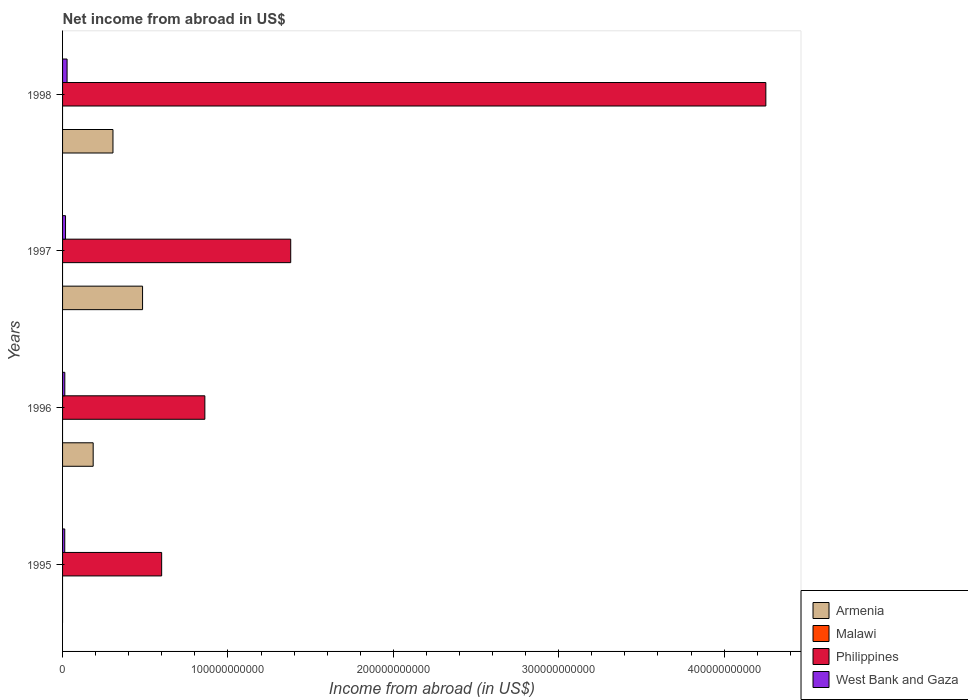Are the number of bars per tick equal to the number of legend labels?
Offer a very short reply. No. How many bars are there on the 4th tick from the bottom?
Your answer should be compact. 3. What is the label of the 2nd group of bars from the top?
Offer a very short reply. 1997. What is the net income from abroad in Philippines in 1996?
Offer a very short reply. 8.60e+1. Across all years, what is the maximum net income from abroad in Philippines?
Provide a succinct answer. 4.25e+11. In which year was the net income from abroad in Armenia maximum?
Provide a short and direct response. 1997. What is the total net income from abroad in West Bank and Gaza in the graph?
Make the answer very short. 7.20e+09. What is the difference between the net income from abroad in Philippines in 1996 and that in 1997?
Provide a short and direct response. -5.19e+1. What is the difference between the net income from abroad in Malawi in 1998 and the net income from abroad in Philippines in 1997?
Keep it short and to the point. -1.38e+11. What is the average net income from abroad in Philippines per year?
Offer a very short reply. 1.77e+11. In the year 1998, what is the difference between the net income from abroad in Armenia and net income from abroad in West Bank and Gaza?
Offer a terse response. 2.77e+1. In how many years, is the net income from abroad in Armenia greater than 420000000000 US$?
Give a very brief answer. 0. What is the ratio of the net income from abroad in Philippines in 1995 to that in 1998?
Your answer should be very brief. 0.14. Is the net income from abroad in Philippines in 1996 less than that in 1997?
Offer a very short reply. Yes. Is the difference between the net income from abroad in Armenia in 1996 and 1997 greater than the difference between the net income from abroad in West Bank and Gaza in 1996 and 1997?
Provide a succinct answer. No. What is the difference between the highest and the second highest net income from abroad in Philippines?
Provide a succinct answer. 2.87e+11. What is the difference between the highest and the lowest net income from abroad in West Bank and Gaza?
Give a very brief answer. 1.41e+09. Is the sum of the net income from abroad in West Bank and Gaza in 1995 and 1996 greater than the maximum net income from abroad in Armenia across all years?
Your answer should be very brief. No. Is it the case that in every year, the sum of the net income from abroad in West Bank and Gaza and net income from abroad in Philippines is greater than the sum of net income from abroad in Armenia and net income from abroad in Malawi?
Your answer should be very brief. Yes. How many bars are there?
Your answer should be compact. 11. Are all the bars in the graph horizontal?
Your answer should be compact. Yes. What is the difference between two consecutive major ticks on the X-axis?
Your response must be concise. 1.00e+11. Are the values on the major ticks of X-axis written in scientific E-notation?
Provide a short and direct response. No. Does the graph contain grids?
Offer a terse response. No. Where does the legend appear in the graph?
Offer a terse response. Bottom right. How are the legend labels stacked?
Make the answer very short. Vertical. What is the title of the graph?
Make the answer very short. Net income from abroad in US$. Does "Czech Republic" appear as one of the legend labels in the graph?
Make the answer very short. No. What is the label or title of the X-axis?
Give a very brief answer. Income from abroad (in US$). What is the Income from abroad (in US$) in Armenia in 1995?
Your answer should be very brief. 0. What is the Income from abroad (in US$) of Philippines in 1995?
Offer a very short reply. 5.99e+1. What is the Income from abroad (in US$) of West Bank and Gaza in 1995?
Offer a terse response. 1.32e+09. What is the Income from abroad (in US$) in Armenia in 1996?
Offer a terse response. 1.85e+1. What is the Income from abroad (in US$) of Philippines in 1996?
Ensure brevity in your answer.  8.60e+1. What is the Income from abroad (in US$) of West Bank and Gaza in 1996?
Make the answer very short. 1.35e+09. What is the Income from abroad (in US$) in Armenia in 1997?
Provide a short and direct response. 4.84e+1. What is the Income from abroad (in US$) in Malawi in 1997?
Your answer should be compact. 0. What is the Income from abroad (in US$) in Philippines in 1997?
Your answer should be compact. 1.38e+11. What is the Income from abroad (in US$) in West Bank and Gaza in 1997?
Provide a short and direct response. 1.80e+09. What is the Income from abroad (in US$) of Armenia in 1998?
Your response must be concise. 3.05e+1. What is the Income from abroad (in US$) in Philippines in 1998?
Offer a very short reply. 4.25e+11. What is the Income from abroad (in US$) in West Bank and Gaza in 1998?
Your answer should be compact. 2.73e+09. Across all years, what is the maximum Income from abroad (in US$) in Armenia?
Offer a very short reply. 4.84e+1. Across all years, what is the maximum Income from abroad (in US$) in Philippines?
Your answer should be very brief. 4.25e+11. Across all years, what is the maximum Income from abroad (in US$) in West Bank and Gaza?
Your answer should be very brief. 2.73e+09. Across all years, what is the minimum Income from abroad (in US$) in Philippines?
Keep it short and to the point. 5.99e+1. Across all years, what is the minimum Income from abroad (in US$) of West Bank and Gaza?
Your answer should be very brief. 1.32e+09. What is the total Income from abroad (in US$) of Armenia in the graph?
Your answer should be compact. 9.74e+1. What is the total Income from abroad (in US$) of Malawi in the graph?
Provide a succinct answer. 0. What is the total Income from abroad (in US$) of Philippines in the graph?
Ensure brevity in your answer.  7.09e+11. What is the total Income from abroad (in US$) of West Bank and Gaza in the graph?
Your answer should be very brief. 7.20e+09. What is the difference between the Income from abroad (in US$) of Philippines in 1995 and that in 1996?
Your response must be concise. -2.61e+1. What is the difference between the Income from abroad (in US$) in West Bank and Gaza in 1995 and that in 1996?
Keep it short and to the point. -3.00e+07. What is the difference between the Income from abroad (in US$) in Philippines in 1995 and that in 1997?
Ensure brevity in your answer.  -7.80e+1. What is the difference between the Income from abroad (in US$) in West Bank and Gaza in 1995 and that in 1997?
Your answer should be very brief. -4.71e+08. What is the difference between the Income from abroad (in US$) in Philippines in 1995 and that in 1998?
Your answer should be very brief. -3.65e+11. What is the difference between the Income from abroad (in US$) in West Bank and Gaza in 1995 and that in 1998?
Offer a very short reply. -1.41e+09. What is the difference between the Income from abroad (in US$) in Armenia in 1996 and that in 1997?
Provide a short and direct response. -2.99e+1. What is the difference between the Income from abroad (in US$) of Philippines in 1996 and that in 1997?
Offer a very short reply. -5.19e+1. What is the difference between the Income from abroad (in US$) of West Bank and Gaza in 1996 and that in 1997?
Offer a very short reply. -4.41e+08. What is the difference between the Income from abroad (in US$) of Armenia in 1996 and that in 1998?
Make the answer very short. -1.20e+1. What is the difference between the Income from abroad (in US$) in Philippines in 1996 and that in 1998?
Ensure brevity in your answer.  -3.39e+11. What is the difference between the Income from abroad (in US$) of West Bank and Gaza in 1996 and that in 1998?
Provide a succinct answer. -1.38e+09. What is the difference between the Income from abroad (in US$) of Armenia in 1997 and that in 1998?
Provide a succinct answer. 1.79e+1. What is the difference between the Income from abroad (in US$) in Philippines in 1997 and that in 1998?
Your answer should be compact. -2.87e+11. What is the difference between the Income from abroad (in US$) of West Bank and Gaza in 1997 and that in 1998?
Keep it short and to the point. -9.36e+08. What is the difference between the Income from abroad (in US$) of Philippines in 1995 and the Income from abroad (in US$) of West Bank and Gaza in 1996?
Your answer should be compact. 5.86e+1. What is the difference between the Income from abroad (in US$) in Philippines in 1995 and the Income from abroad (in US$) in West Bank and Gaza in 1997?
Your answer should be very brief. 5.81e+1. What is the difference between the Income from abroad (in US$) in Philippines in 1995 and the Income from abroad (in US$) in West Bank and Gaza in 1998?
Ensure brevity in your answer.  5.72e+1. What is the difference between the Income from abroad (in US$) in Armenia in 1996 and the Income from abroad (in US$) in Philippines in 1997?
Give a very brief answer. -1.19e+11. What is the difference between the Income from abroad (in US$) of Armenia in 1996 and the Income from abroad (in US$) of West Bank and Gaza in 1997?
Your answer should be compact. 1.67e+1. What is the difference between the Income from abroad (in US$) in Philippines in 1996 and the Income from abroad (in US$) in West Bank and Gaza in 1997?
Give a very brief answer. 8.42e+1. What is the difference between the Income from abroad (in US$) in Armenia in 1996 and the Income from abroad (in US$) in Philippines in 1998?
Give a very brief answer. -4.07e+11. What is the difference between the Income from abroad (in US$) of Armenia in 1996 and the Income from abroad (in US$) of West Bank and Gaza in 1998?
Provide a short and direct response. 1.58e+1. What is the difference between the Income from abroad (in US$) of Philippines in 1996 and the Income from abroad (in US$) of West Bank and Gaza in 1998?
Ensure brevity in your answer.  8.33e+1. What is the difference between the Income from abroad (in US$) in Armenia in 1997 and the Income from abroad (in US$) in Philippines in 1998?
Your response must be concise. -3.77e+11. What is the difference between the Income from abroad (in US$) of Armenia in 1997 and the Income from abroad (in US$) of West Bank and Gaza in 1998?
Offer a terse response. 4.56e+1. What is the difference between the Income from abroad (in US$) in Philippines in 1997 and the Income from abroad (in US$) in West Bank and Gaza in 1998?
Your answer should be compact. 1.35e+11. What is the average Income from abroad (in US$) of Armenia per year?
Keep it short and to the point. 2.43e+1. What is the average Income from abroad (in US$) in Philippines per year?
Keep it short and to the point. 1.77e+11. What is the average Income from abroad (in US$) of West Bank and Gaza per year?
Make the answer very short. 1.80e+09. In the year 1995, what is the difference between the Income from abroad (in US$) in Philippines and Income from abroad (in US$) in West Bank and Gaza?
Your response must be concise. 5.86e+1. In the year 1996, what is the difference between the Income from abroad (in US$) of Armenia and Income from abroad (in US$) of Philippines?
Your answer should be very brief. -6.75e+1. In the year 1996, what is the difference between the Income from abroad (in US$) in Armenia and Income from abroad (in US$) in West Bank and Gaza?
Your answer should be very brief. 1.72e+1. In the year 1996, what is the difference between the Income from abroad (in US$) of Philippines and Income from abroad (in US$) of West Bank and Gaza?
Offer a terse response. 8.47e+1. In the year 1997, what is the difference between the Income from abroad (in US$) in Armenia and Income from abroad (in US$) in Philippines?
Offer a very short reply. -8.96e+1. In the year 1997, what is the difference between the Income from abroad (in US$) of Armenia and Income from abroad (in US$) of West Bank and Gaza?
Give a very brief answer. 4.66e+1. In the year 1997, what is the difference between the Income from abroad (in US$) in Philippines and Income from abroad (in US$) in West Bank and Gaza?
Your answer should be compact. 1.36e+11. In the year 1998, what is the difference between the Income from abroad (in US$) of Armenia and Income from abroad (in US$) of Philippines?
Provide a short and direct response. -3.95e+11. In the year 1998, what is the difference between the Income from abroad (in US$) in Armenia and Income from abroad (in US$) in West Bank and Gaza?
Offer a terse response. 2.77e+1. In the year 1998, what is the difference between the Income from abroad (in US$) in Philippines and Income from abroad (in US$) in West Bank and Gaza?
Give a very brief answer. 4.23e+11. What is the ratio of the Income from abroad (in US$) of Philippines in 1995 to that in 1996?
Provide a short and direct response. 0.7. What is the ratio of the Income from abroad (in US$) in West Bank and Gaza in 1995 to that in 1996?
Ensure brevity in your answer.  0.98. What is the ratio of the Income from abroad (in US$) of Philippines in 1995 to that in 1997?
Make the answer very short. 0.43. What is the ratio of the Income from abroad (in US$) in West Bank and Gaza in 1995 to that in 1997?
Your response must be concise. 0.74. What is the ratio of the Income from abroad (in US$) in Philippines in 1995 to that in 1998?
Offer a terse response. 0.14. What is the ratio of the Income from abroad (in US$) in West Bank and Gaza in 1995 to that in 1998?
Give a very brief answer. 0.48. What is the ratio of the Income from abroad (in US$) of Armenia in 1996 to that in 1997?
Keep it short and to the point. 0.38. What is the ratio of the Income from abroad (in US$) in Philippines in 1996 to that in 1997?
Your answer should be compact. 0.62. What is the ratio of the Income from abroad (in US$) in West Bank and Gaza in 1996 to that in 1997?
Make the answer very short. 0.75. What is the ratio of the Income from abroad (in US$) of Armenia in 1996 to that in 1998?
Keep it short and to the point. 0.61. What is the ratio of the Income from abroad (in US$) of Philippines in 1996 to that in 1998?
Ensure brevity in your answer.  0.2. What is the ratio of the Income from abroad (in US$) of West Bank and Gaza in 1996 to that in 1998?
Keep it short and to the point. 0.5. What is the ratio of the Income from abroad (in US$) in Armenia in 1997 to that in 1998?
Your response must be concise. 1.59. What is the ratio of the Income from abroad (in US$) in Philippines in 1997 to that in 1998?
Offer a terse response. 0.32. What is the ratio of the Income from abroad (in US$) of West Bank and Gaza in 1997 to that in 1998?
Give a very brief answer. 0.66. What is the difference between the highest and the second highest Income from abroad (in US$) of Armenia?
Offer a terse response. 1.79e+1. What is the difference between the highest and the second highest Income from abroad (in US$) in Philippines?
Your response must be concise. 2.87e+11. What is the difference between the highest and the second highest Income from abroad (in US$) of West Bank and Gaza?
Provide a succinct answer. 9.36e+08. What is the difference between the highest and the lowest Income from abroad (in US$) of Armenia?
Offer a very short reply. 4.84e+1. What is the difference between the highest and the lowest Income from abroad (in US$) in Philippines?
Offer a terse response. 3.65e+11. What is the difference between the highest and the lowest Income from abroad (in US$) of West Bank and Gaza?
Ensure brevity in your answer.  1.41e+09. 